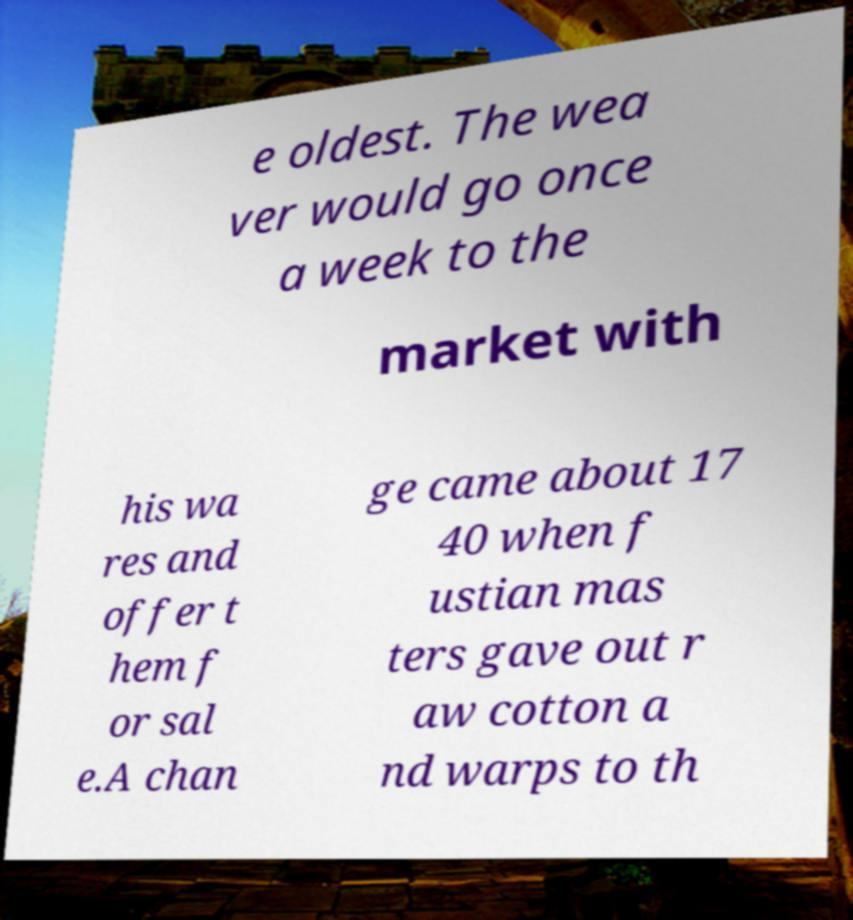I need the written content from this picture converted into text. Can you do that? e oldest. The wea ver would go once a week to the market with his wa res and offer t hem f or sal e.A chan ge came about 17 40 when f ustian mas ters gave out r aw cotton a nd warps to th 